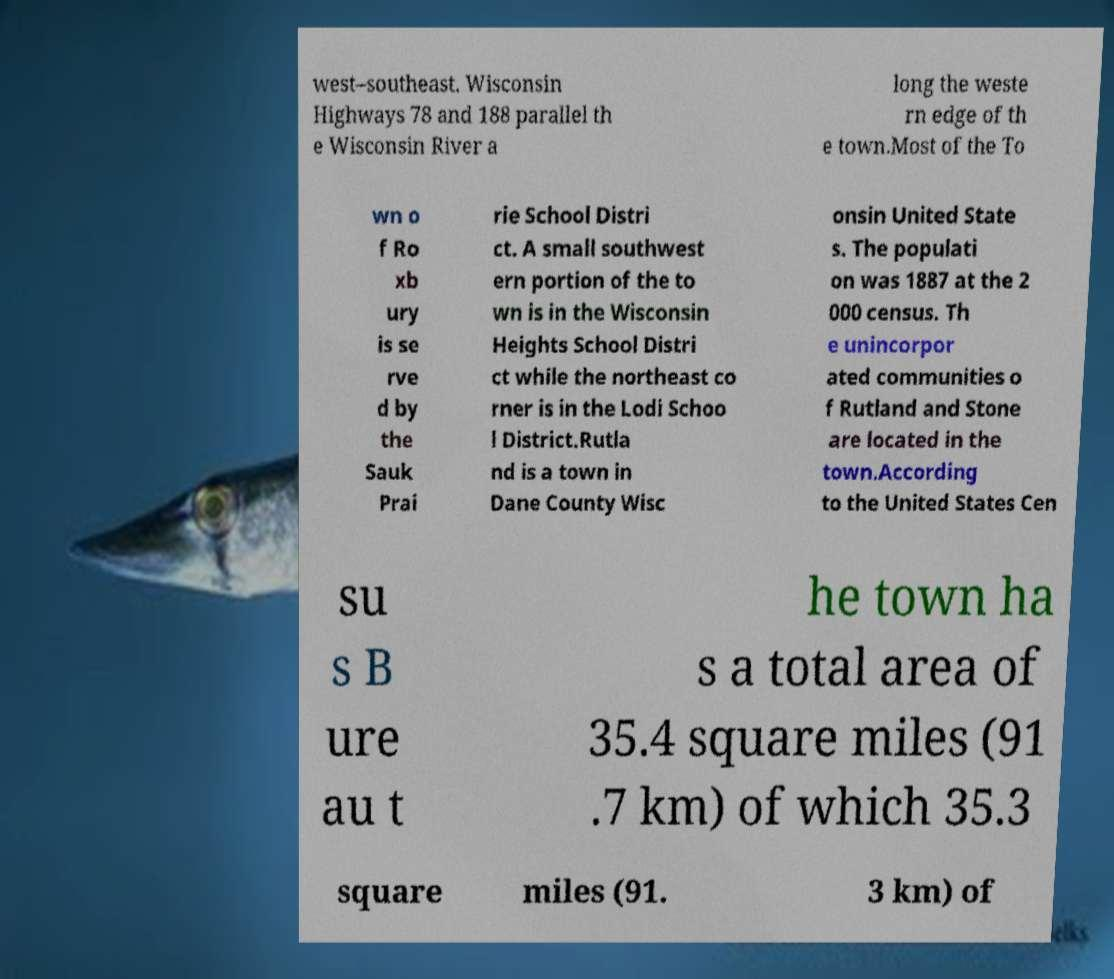Could you extract and type out the text from this image? west–southeast. Wisconsin Highways 78 and 188 parallel th e Wisconsin River a long the weste rn edge of th e town.Most of the To wn o f Ro xb ury is se rve d by the Sauk Prai rie School Distri ct. A small southwest ern portion of the to wn is in the Wisconsin Heights School Distri ct while the northeast co rner is in the Lodi Schoo l District.Rutla nd is a town in Dane County Wisc onsin United State s. The populati on was 1887 at the 2 000 census. Th e unincorpor ated communities o f Rutland and Stone are located in the town.According to the United States Cen su s B ure au t he town ha s a total area of 35.4 square miles (91 .7 km) of which 35.3 square miles (91. 3 km) of 